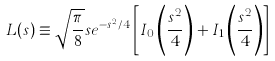<formula> <loc_0><loc_0><loc_500><loc_500>L ( s ) \equiv \sqrt { \frac { \pi } { 8 } } s e ^ { - s ^ { 2 } / 4 } \left [ I _ { 0 } \left ( \frac { s ^ { 2 } } { 4 } \right ) + I _ { 1 } \left ( \frac { s ^ { 2 } } { 4 } \right ) \right ]</formula> 